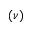<formula> <loc_0><loc_0><loc_500><loc_500>( \nu )</formula> 